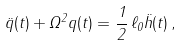<formula> <loc_0><loc_0><loc_500><loc_500>\ddot { q } ( t ) + \Omega ^ { 2 } q ( t ) = \frac { 1 } { 2 } \, \ell _ { 0 } \ddot { h } ( t ) \, ,</formula> 